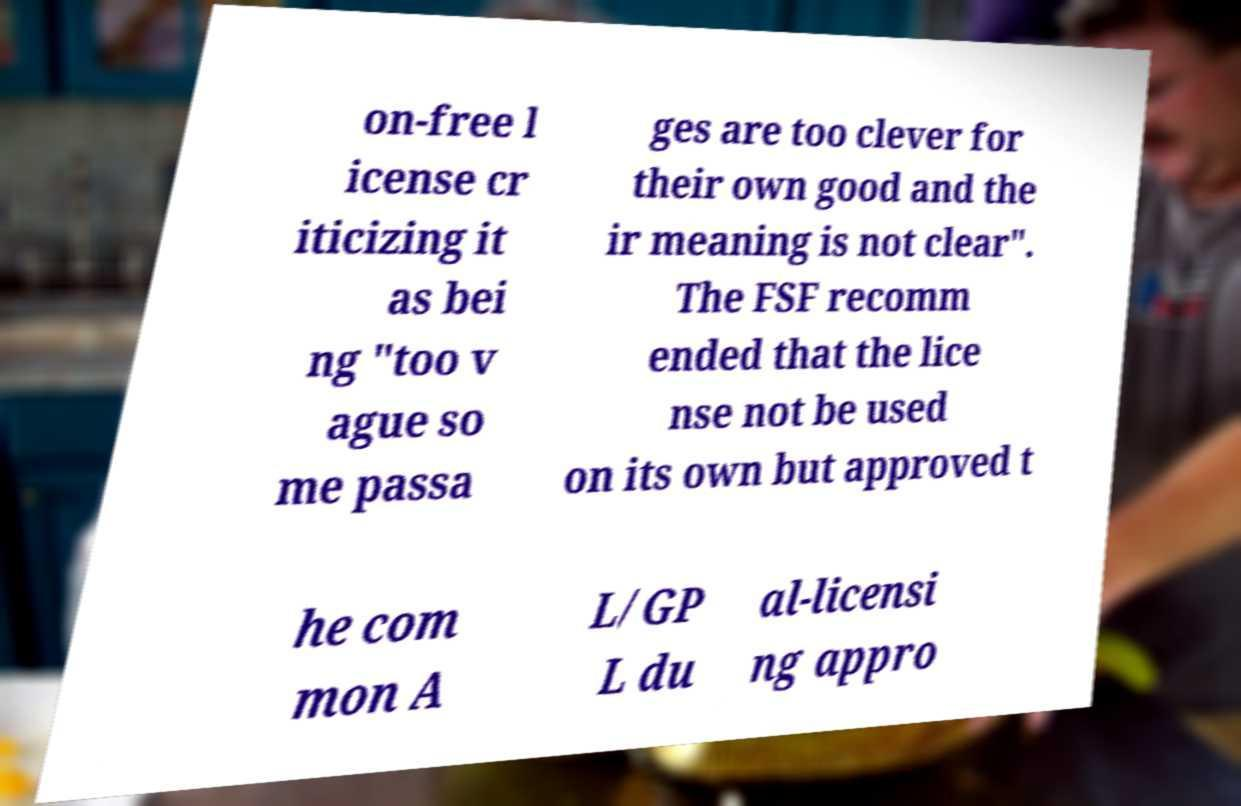Please read and relay the text visible in this image. What does it say? on-free l icense cr iticizing it as bei ng "too v ague so me passa ges are too clever for their own good and the ir meaning is not clear". The FSF recomm ended that the lice nse not be used on its own but approved t he com mon A L/GP L du al-licensi ng appro 